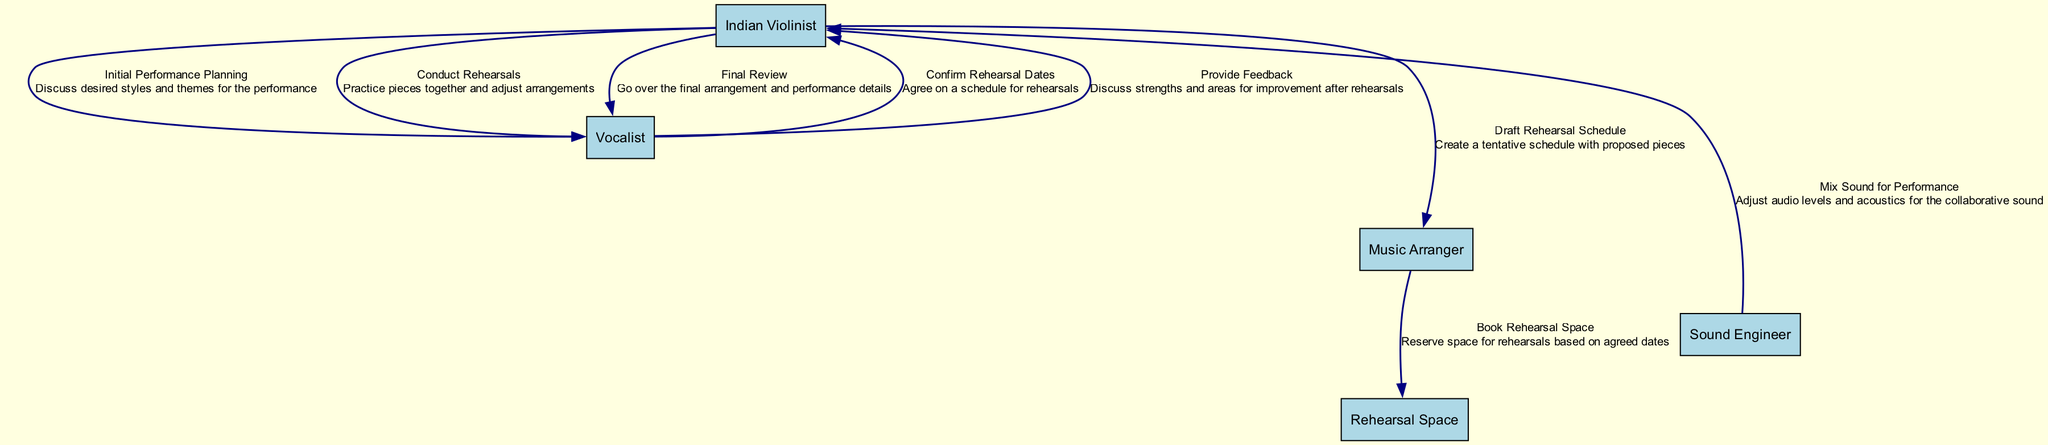What action begins the performance planning process? The first action in the diagram is "Initial Performance Planning," which is initiated by the Indian Violinist discussing desired styles and themes for the performance with the Vocalist.
Answer: Initial Performance Planning Who books the rehearsal space? The Music Arranger is responsible for booking the rehearsal space as indicated in the "Book Rehearsal Space" action.
Answer: Music Arranger How many participants are involved in the sequence diagram? The diagram lists five participants: Indian Violinist, Vocalist, Music Arranger, Sound Engineer, and Rehearsal Space, totaling five.
Answer: Five What is the last action performed in the sequence? The last action in the sequence is "Final Review," where the Indian Violinist goes over the final arrangement and performance details with the Vocalist.
Answer: Final Review Which two participants are involved in providing feedback? The feedback is provided by the Vocalist to the Indian Violinist, as illustrated in the "Provide Feedback" action.
Answer: Vocalist and Indian Violinist What step follows mixing sound for the performance? After "Mix Sound for Performance," the next step is "Final Review," indicating a sequential flow from sound mixing to reviewing.
Answer: Final Review How does the Vocalist contribute after rehearsals? The Vocalist's contribution is in the "Provide Feedback" action, where they discuss strengths and areas for improvement after rehearsals with the Indian Violinist.
Answer: Provide Feedback What is the first step in creating a rehearsal schedule? The first step is "Draft Rehearsal Schedule," where the Indian Violinist creates a tentative schedule with proposed pieces, leading to further arrangements.
Answer: Draft Rehearsal Schedule What type of space is booked for rehearsals? The type of space booked is a "Rehearsal Space," as indicated in the "Book Rehearsal Space" action within the diagram.
Answer: Rehearsal Space 